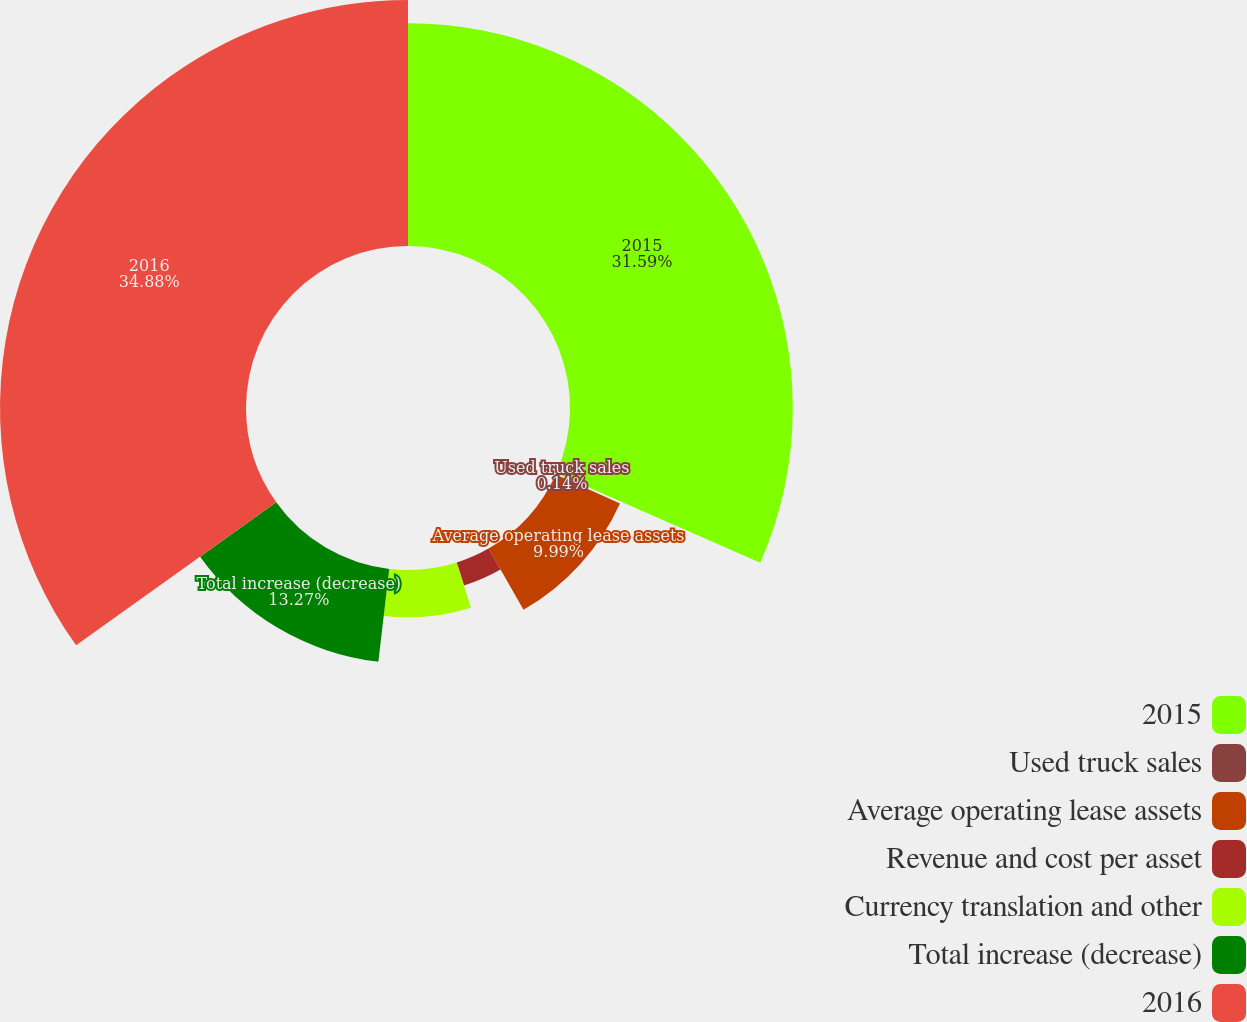Convert chart. <chart><loc_0><loc_0><loc_500><loc_500><pie_chart><fcel>2015<fcel>Used truck sales<fcel>Average operating lease assets<fcel>Revenue and cost per asset<fcel>Currency translation and other<fcel>Total increase (decrease)<fcel>2016<nl><fcel>31.59%<fcel>0.14%<fcel>9.99%<fcel>3.42%<fcel>6.71%<fcel>13.27%<fcel>34.88%<nl></chart> 